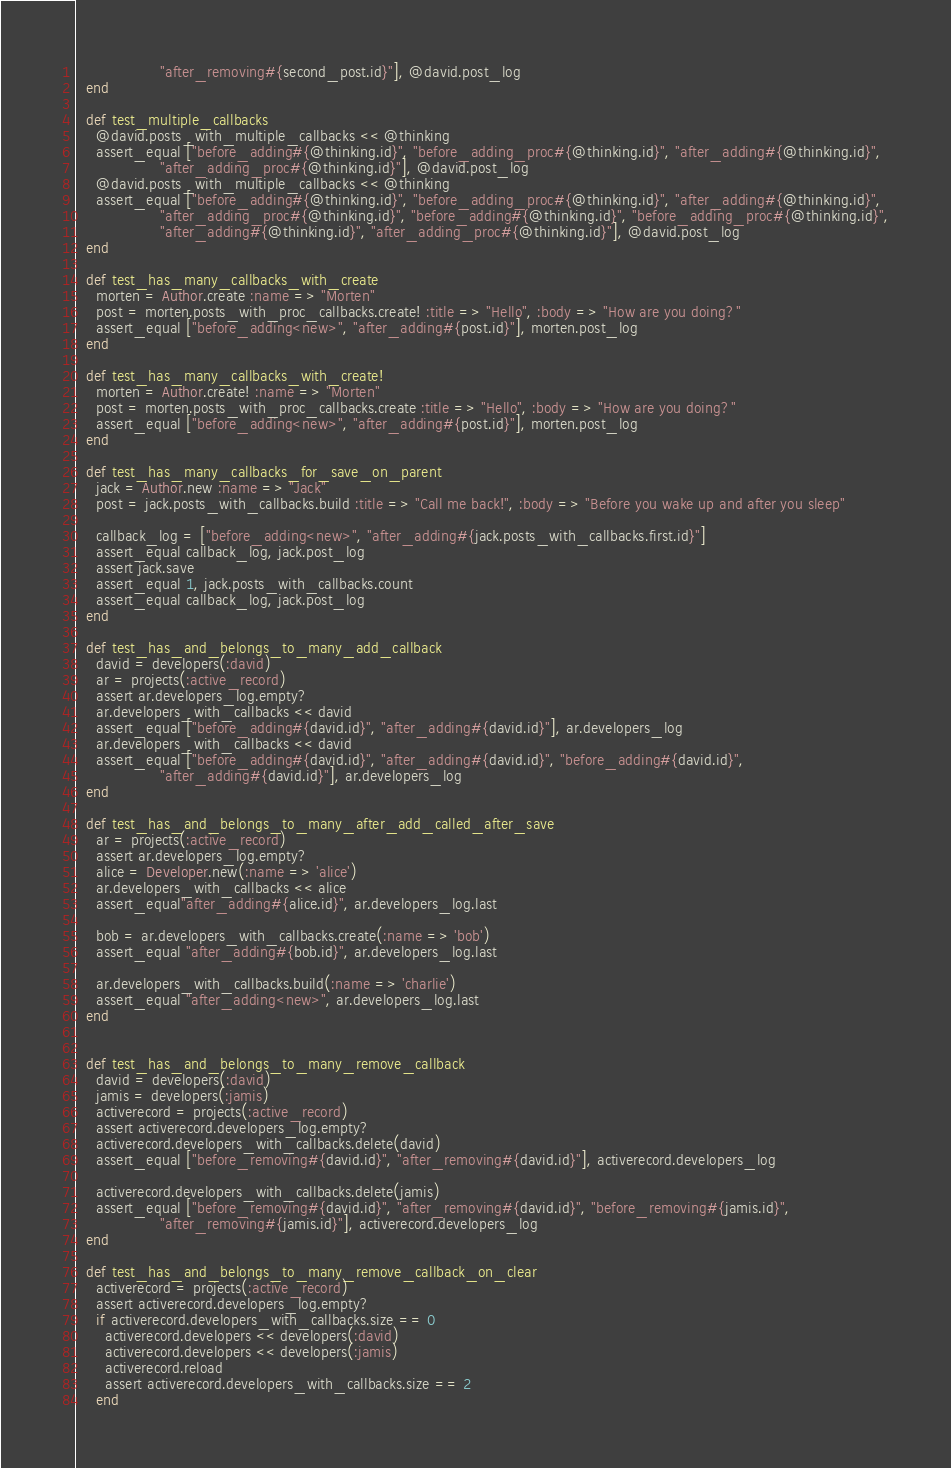Convert code to text. <code><loc_0><loc_0><loc_500><loc_500><_Ruby_>                  "after_removing#{second_post.id}"], @david.post_log
  end

  def test_multiple_callbacks
    @david.posts_with_multiple_callbacks << @thinking
    assert_equal ["before_adding#{@thinking.id}", "before_adding_proc#{@thinking.id}", "after_adding#{@thinking.id}",
                  "after_adding_proc#{@thinking.id}"], @david.post_log
    @david.posts_with_multiple_callbacks << @thinking
    assert_equal ["before_adding#{@thinking.id}", "before_adding_proc#{@thinking.id}", "after_adding#{@thinking.id}",
                  "after_adding_proc#{@thinking.id}", "before_adding#{@thinking.id}", "before_adding_proc#{@thinking.id}",
                  "after_adding#{@thinking.id}", "after_adding_proc#{@thinking.id}"], @david.post_log
  end

  def test_has_many_callbacks_with_create
    morten = Author.create :name => "Morten"
    post = morten.posts_with_proc_callbacks.create! :title => "Hello", :body => "How are you doing?"
    assert_equal ["before_adding<new>", "after_adding#{post.id}"], morten.post_log
  end

  def test_has_many_callbacks_with_create!
    morten = Author.create! :name => "Morten"
    post = morten.posts_with_proc_callbacks.create :title => "Hello", :body => "How are you doing?"
    assert_equal ["before_adding<new>", "after_adding#{post.id}"], morten.post_log
  end

  def test_has_many_callbacks_for_save_on_parent
    jack = Author.new :name => "Jack"
    post = jack.posts_with_callbacks.build :title => "Call me back!", :body => "Before you wake up and after you sleep"

    callback_log = ["before_adding<new>", "after_adding#{jack.posts_with_callbacks.first.id}"]
    assert_equal callback_log, jack.post_log
    assert jack.save
    assert_equal 1, jack.posts_with_callbacks.count
    assert_equal callback_log, jack.post_log
  end

  def test_has_and_belongs_to_many_add_callback
    david = developers(:david)
    ar = projects(:active_record)
    assert ar.developers_log.empty?
    ar.developers_with_callbacks << david
    assert_equal ["before_adding#{david.id}", "after_adding#{david.id}"], ar.developers_log
    ar.developers_with_callbacks << david
    assert_equal ["before_adding#{david.id}", "after_adding#{david.id}", "before_adding#{david.id}",
                  "after_adding#{david.id}"], ar.developers_log
  end

  def test_has_and_belongs_to_many_after_add_called_after_save
    ar = projects(:active_record)
    assert ar.developers_log.empty?
    alice = Developer.new(:name => 'alice')
    ar.developers_with_callbacks << alice
    assert_equal"after_adding#{alice.id}", ar.developers_log.last

    bob = ar.developers_with_callbacks.create(:name => 'bob')
    assert_equal "after_adding#{bob.id}", ar.developers_log.last

    ar.developers_with_callbacks.build(:name => 'charlie')
    assert_equal "after_adding<new>", ar.developers_log.last
  end


  def test_has_and_belongs_to_many_remove_callback
    david = developers(:david)
    jamis = developers(:jamis)
    activerecord = projects(:active_record)
    assert activerecord.developers_log.empty?
    activerecord.developers_with_callbacks.delete(david)
    assert_equal ["before_removing#{david.id}", "after_removing#{david.id}"], activerecord.developers_log

    activerecord.developers_with_callbacks.delete(jamis)
    assert_equal ["before_removing#{david.id}", "after_removing#{david.id}", "before_removing#{jamis.id}",
                  "after_removing#{jamis.id}"], activerecord.developers_log
  end

  def test_has_and_belongs_to_many_remove_callback_on_clear
    activerecord = projects(:active_record)
    assert activerecord.developers_log.empty?
    if activerecord.developers_with_callbacks.size == 0
      activerecord.developers << developers(:david)
      activerecord.developers << developers(:jamis)
      activerecord.reload
      assert activerecord.developers_with_callbacks.size == 2
    end</code> 